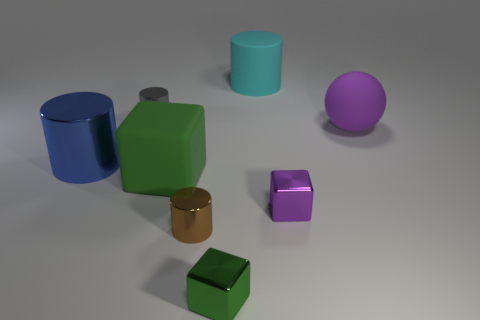There is a thing that is the same color as the big ball; what size is it?
Make the answer very short. Small. Does the cube on the left side of the brown cylinder have the same color as the tiny object that is in front of the brown cylinder?
Provide a succinct answer. Yes. There is a ball that is the same size as the blue metal cylinder; what is it made of?
Provide a succinct answer. Rubber. There is a metallic cylinder that is to the right of the matte object that is left of the green block in front of the small purple metallic block; what size is it?
Provide a succinct answer. Small. How many other objects are the same material as the brown cylinder?
Make the answer very short. 4. There is a metallic cylinder on the right side of the small gray metal thing; how big is it?
Make the answer very short. Small. What number of rubber objects are on the right side of the brown metallic thing and left of the purple metal thing?
Your answer should be compact. 1. There is a green object that is to the left of the tiny cylinder in front of the green matte cube; what is its material?
Your response must be concise. Rubber. What is the material of the small gray thing that is the same shape as the blue object?
Your answer should be compact. Metal. Are any spheres visible?
Make the answer very short. Yes. 